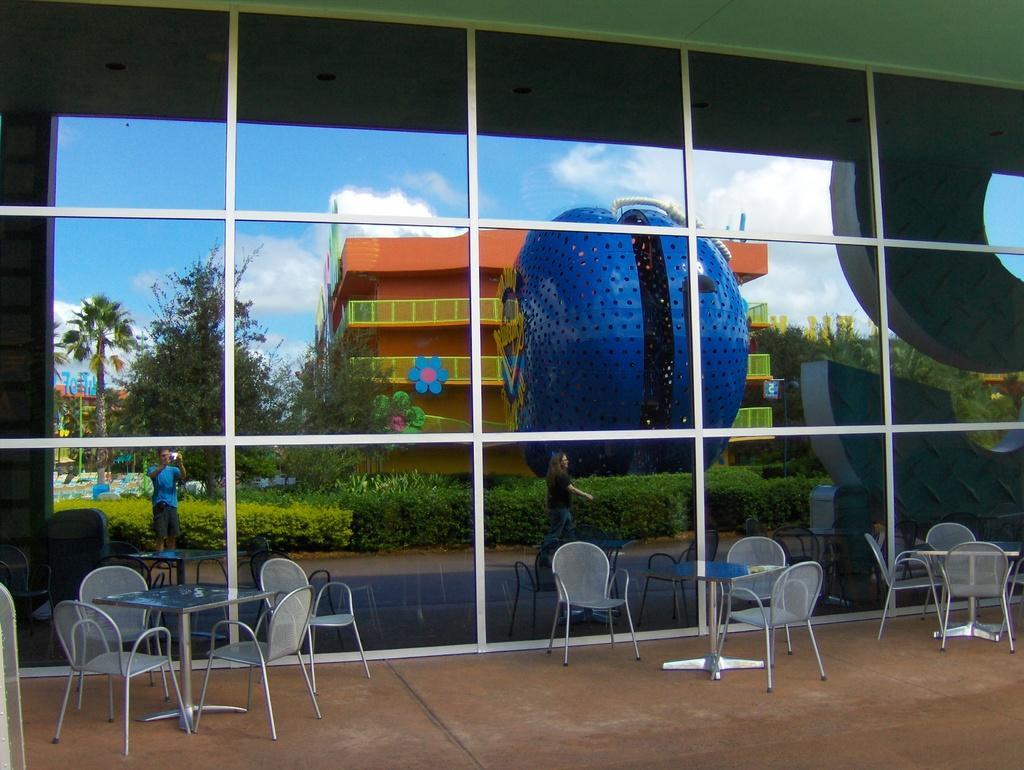Can you describe this image briefly? In this image we can see a glass wall. In front of the wall tables and chairs are there. In the reflection we can see building, plats and trees. The sky is in blue color with some cloud and one blue color structure is present. 